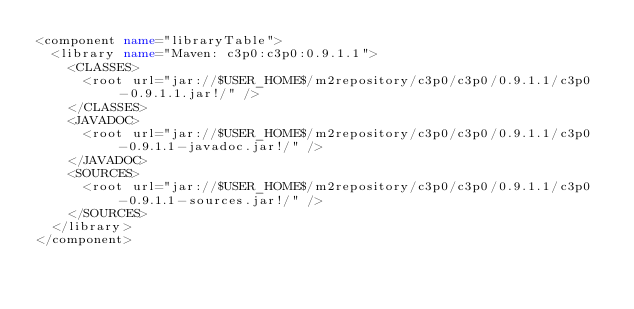Convert code to text. <code><loc_0><loc_0><loc_500><loc_500><_XML_><component name="libraryTable">
  <library name="Maven: c3p0:c3p0:0.9.1.1">
    <CLASSES>
      <root url="jar://$USER_HOME$/m2repository/c3p0/c3p0/0.9.1.1/c3p0-0.9.1.1.jar!/" />
    </CLASSES>
    <JAVADOC>
      <root url="jar://$USER_HOME$/m2repository/c3p0/c3p0/0.9.1.1/c3p0-0.9.1.1-javadoc.jar!/" />
    </JAVADOC>
    <SOURCES>
      <root url="jar://$USER_HOME$/m2repository/c3p0/c3p0/0.9.1.1/c3p0-0.9.1.1-sources.jar!/" />
    </SOURCES>
  </library>
</component></code> 